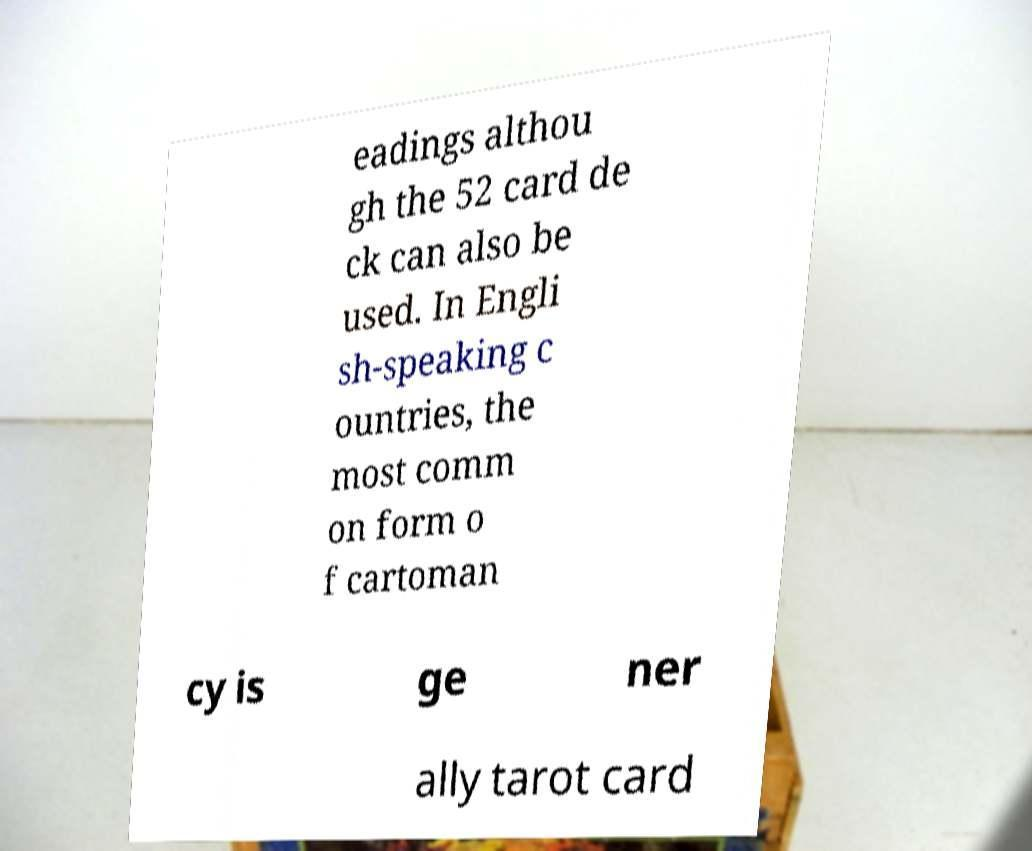For documentation purposes, I need the text within this image transcribed. Could you provide that? eadings althou gh the 52 card de ck can also be used. In Engli sh-speaking c ountries, the most comm on form o f cartoman cy is ge ner ally tarot card 